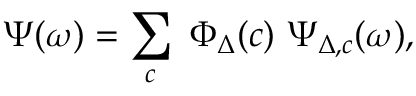Convert formula to latex. <formula><loc_0><loc_0><loc_500><loc_500>\Psi ( \omega ) = \sum _ { c } \ \Phi _ { \Delta } ( c ) \ \Psi _ { \Delta , c } ( \omega ) ,</formula> 